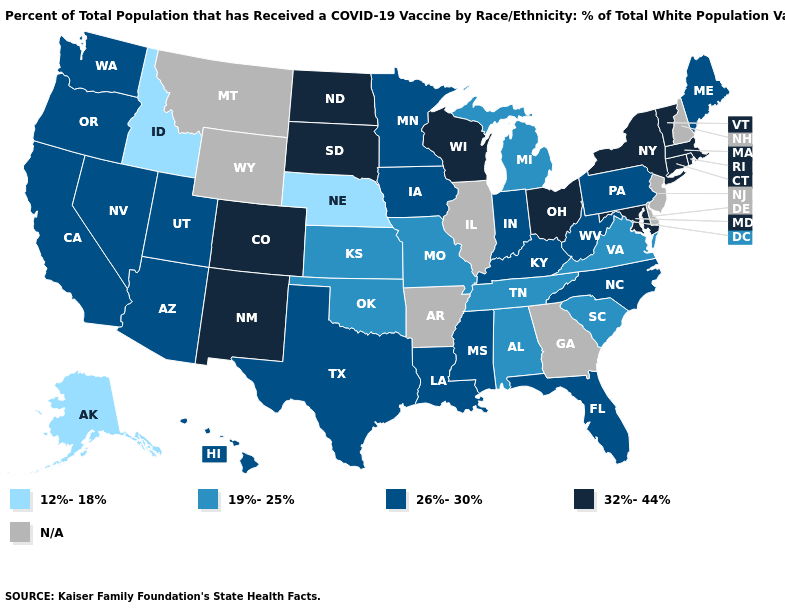Is the legend a continuous bar?
Concise answer only. No. Name the states that have a value in the range N/A?
Concise answer only. Arkansas, Delaware, Georgia, Illinois, Montana, New Hampshire, New Jersey, Wyoming. What is the value of Indiana?
Be succinct. 26%-30%. What is the value of California?
Write a very short answer. 26%-30%. What is the highest value in states that border Utah?
Give a very brief answer. 32%-44%. Name the states that have a value in the range 26%-30%?
Answer briefly. Arizona, California, Florida, Hawaii, Indiana, Iowa, Kentucky, Louisiana, Maine, Minnesota, Mississippi, Nevada, North Carolina, Oregon, Pennsylvania, Texas, Utah, Washington, West Virginia. What is the value of Idaho?
Short answer required. 12%-18%. Which states have the highest value in the USA?
Keep it brief. Colorado, Connecticut, Maryland, Massachusetts, New Mexico, New York, North Dakota, Ohio, Rhode Island, South Dakota, Vermont, Wisconsin. Name the states that have a value in the range 12%-18%?
Quick response, please. Alaska, Idaho, Nebraska. Among the states that border New Hampshire , which have the lowest value?
Keep it brief. Maine. What is the value of Utah?
Answer briefly. 26%-30%. Name the states that have a value in the range N/A?
Answer briefly. Arkansas, Delaware, Georgia, Illinois, Montana, New Hampshire, New Jersey, Wyoming. Name the states that have a value in the range 12%-18%?
Be succinct. Alaska, Idaho, Nebraska. What is the lowest value in states that border Texas?
Answer briefly. 19%-25%. Does Maine have the highest value in the Northeast?
Give a very brief answer. No. 